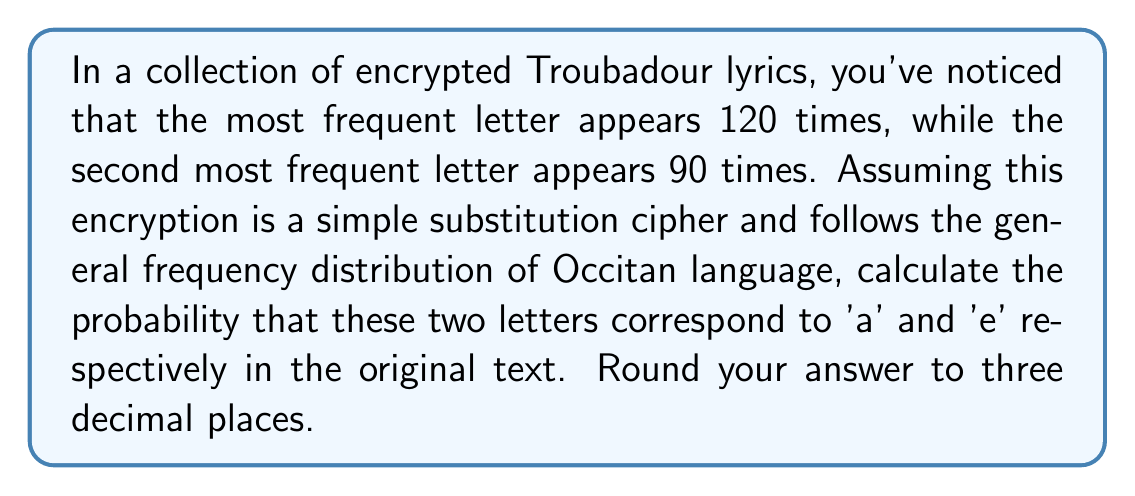Could you help me with this problem? Let's approach this step-by-step:

1) In the Occitan language, 'a' and 'e' are typically the two most frequent letters.

2) Let's define events:
   A: The most frequent letter is 'a'
   E: The second most frequent letter is 'e'

3) We need to calculate $P(A \cap E)$

4) Using the multiplication rule of probability:
   $P(A \cap E) = P(A) \cdot P(E|A)$

5) To estimate $P(A)$, we can use the total count of the two most frequent letters:
   $P(A) = \frac{120}{120+90} = \frac{120}{210} = \frac{4}{7} \approx 0.571$

6) Given that the most frequent letter is 'a', the probability that the second most frequent is 'e' is high. Let's estimate $P(E|A) = 0.9$

7) Now we can calculate:
   $P(A \cap E) = P(A) \cdot P(E|A) = \frac{4}{7} \cdot 0.9 = 0.514$

8) Rounding to three decimal places: 0.514
Answer: 0.514 